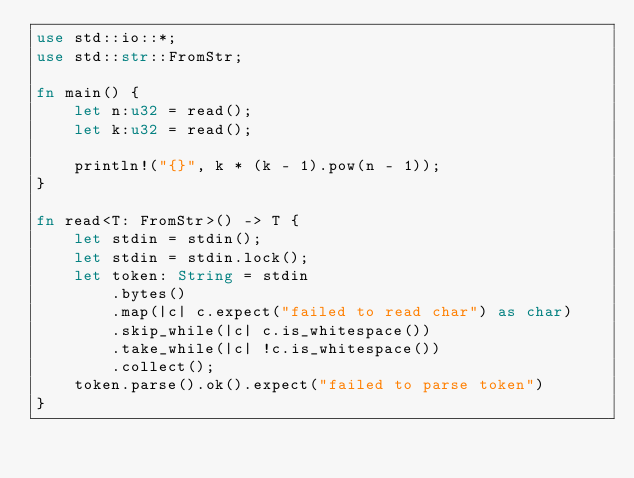Convert code to text. <code><loc_0><loc_0><loc_500><loc_500><_Rust_>use std::io::*;
use std::str::FromStr;

fn main() {
    let n:u32 = read();
    let k:u32 = read();

    println!("{}", k * (k - 1).pow(n - 1));
}

fn read<T: FromStr>() -> T {
    let stdin = stdin();
    let stdin = stdin.lock();
    let token: String = stdin
        .bytes()
        .map(|c| c.expect("failed to read char") as char)
        .skip_while(|c| c.is_whitespace())
        .take_while(|c| !c.is_whitespace())
        .collect();
    token.parse().ok().expect("failed to parse token")
}</code> 